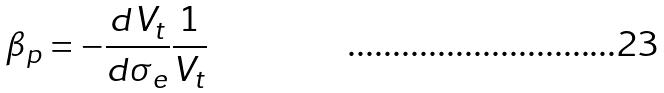Convert formula to latex. <formula><loc_0><loc_0><loc_500><loc_500>\beta _ { p } = - \frac { d V _ { t } } { d \sigma _ { e } } \frac { 1 } { V _ { t } }</formula> 